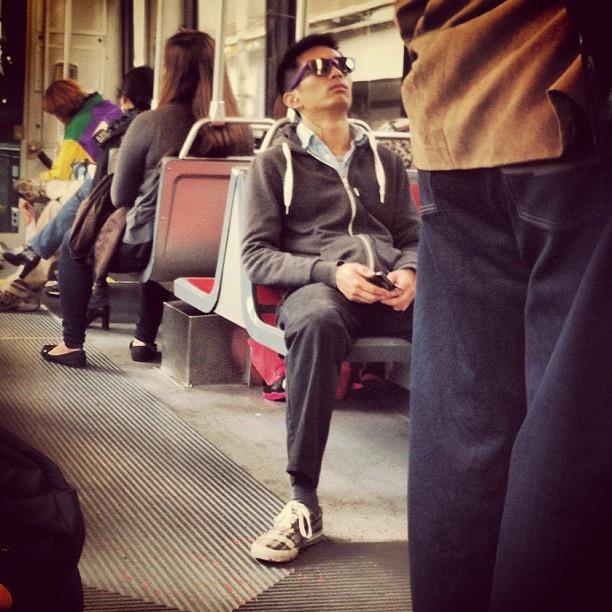Describe the objects in this image and their specific colors. I can see people in maroon, black, and purple tones, people in maroon, black, gray, and darkgray tones, people in maroon, black, and gray tones, chair in maroon, salmon, and brown tones, and chair in maroon, lightgray, gray, and black tones in this image. 